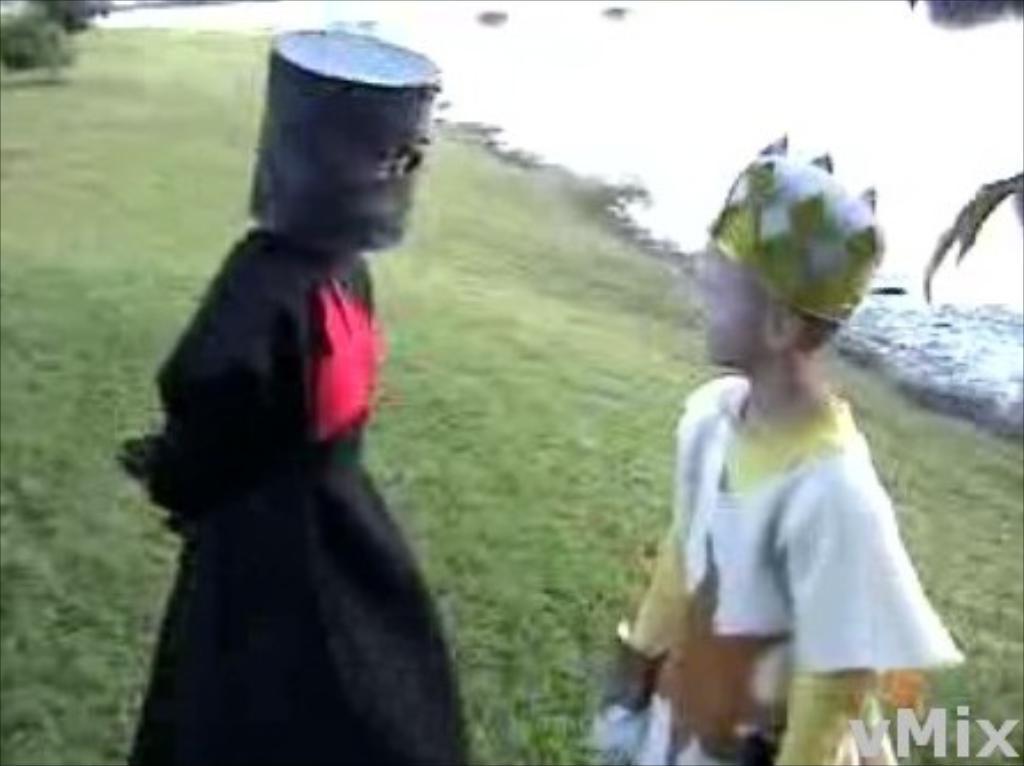How would you summarize this image in a sentence or two? In this picture we can see two persons standing here, they wore costumes, at the bottom there is grass, we can see a watermark here. 